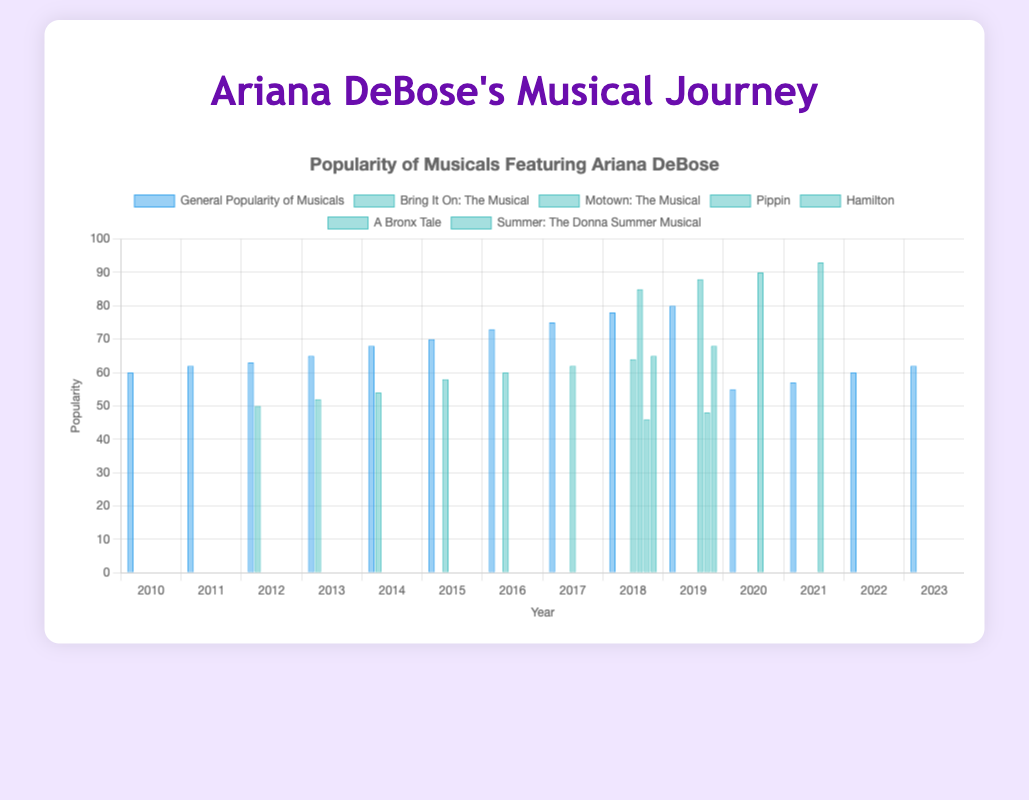Which year had the highest general popularity of musicals? To find this, observe the height of the blue bars for each year. The tallest blue bar represents the highest popularity.
Answer: 2019 In which year did Hamilton reach its peak popularity? According to the data, peak values are shown by the highest blueish-green bar specific to "Hamilton." The tallest bar in this dataset represents its peak popularity.
Answer: 2021 Compare the general popularity of musicals in 2020 with 2021. Look at the blue bars for the years 2020 and 2021 and note their heights. The bar for 2020 is shorter than for 2021.
Answer: 2020 is lower than 2021 Which musicals featuring Ariana DeBose have the highest maximum popularity? Observe the blueish-green bars representing musicals featuring Ariana DeBose. The tallest bar among them indicates the musical with the highest maximum popularity.
Answer: Hamilton How did the popularity of "Bring It On: The Musical" change from 2012 to 2014? Check the heights of the blueish-green bars labeled "Bring It On: The Musical" for 2012, 2013, and 2014. The heights gradually increase from 2012 to 2014.
Answer: Increased During which years was there no recorded popularity for "Motown: The Musical"? Identify the years by noting where there are no blueish-green bars for "Motown: The Musical."
Answer: 2010-2015 and 2017-2023 What is the median general popularity of musicals between 2010 and 2023? List the general popularity values, sort them, and find the middle value. The data sorted is: [55, 57, 60, 60, 62, 62, 63, 65, 68, 70, 73, 75, 78, 80]. The median is the average of 7th and 8th values: (65 + 68)/2 = 66.5.
Answer: 66.5 Which musical featuring Ariana DeBose showed increased popularity after it initially appeared in the chart? Track the changes in heights of the blueish-green bars over the years for each musical listed under Ariana DeBose. "Hamilton" shows increasing popularity after it first appeared.
Answer: Hamilton During which year did "Summer: The Donna Summer Musical" feature in the chart with a given popularity rating? Identify the year by looking for the blueish-green bar labeled "Summer: The Donna Summer Musical" and its height.
Answer: 2018 and 2019 How did the general popularity of musicals change between 2019 and 2020? Compare the heights of the blue bars in 2019 and 2020. The bar in 2020 is significantly shorter than in 2019, indicating a drop.
Answer: Decreased 